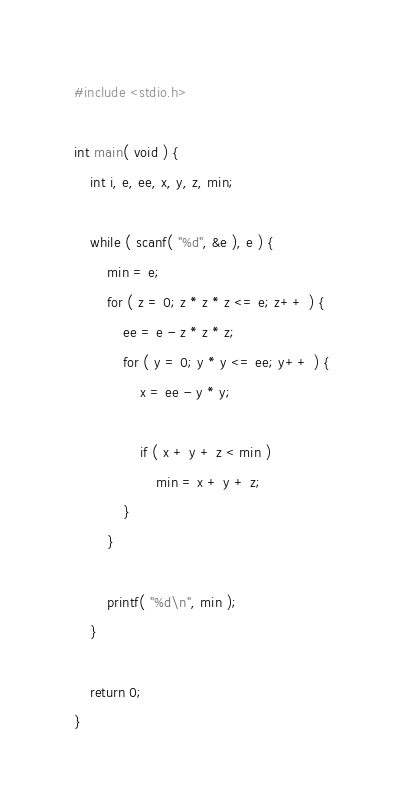Convert code to text. <code><loc_0><loc_0><loc_500><loc_500><_C_>#include <stdio.h>

int main( void ) {
	int i, e, ee, x, y, z, min;

	while ( scanf( "%d", &e ), e ) {
		min = e;
		for ( z = 0; z * z * z <= e; z++ ) {
			ee = e - z * z * z;
			for ( y = 0; y * y <= ee; y++ ) {
				x = ee - y * y;

				if ( x + y + z < min )
					min = x + y + z;
			}
		}

		printf( "%d\n", min );
	}

	return 0;
}</code> 